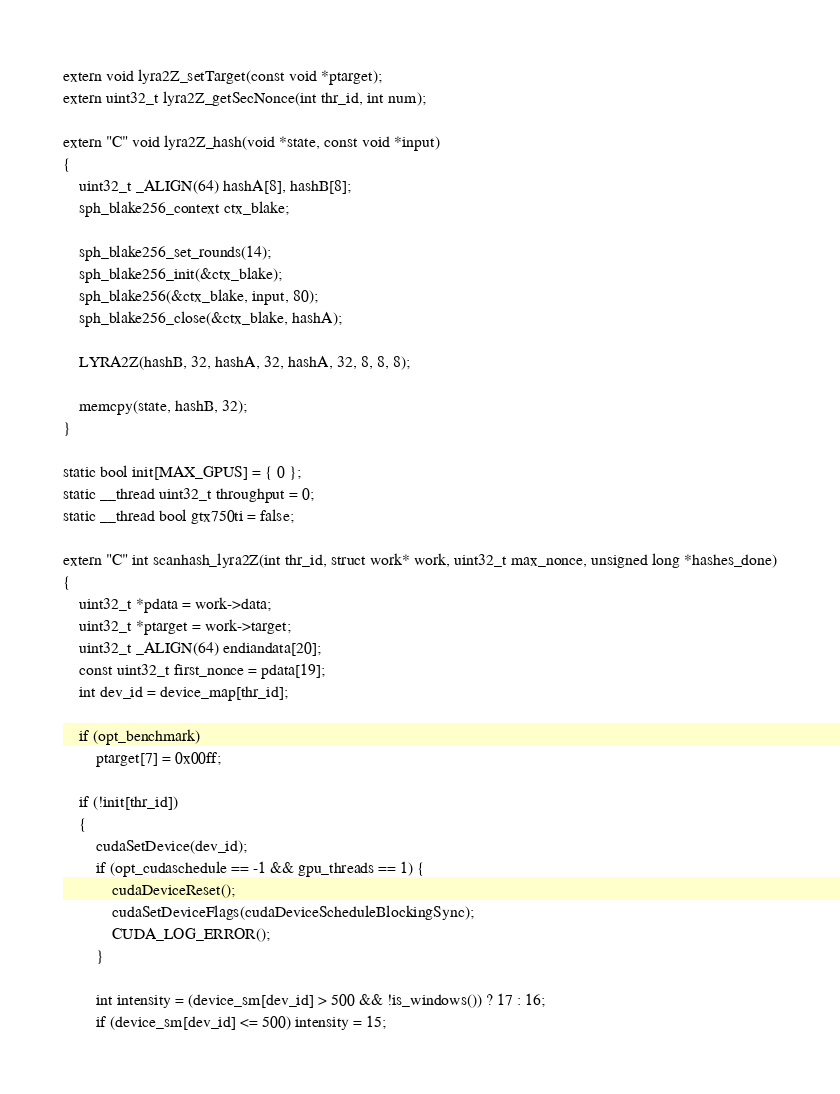<code> <loc_0><loc_0><loc_500><loc_500><_Cuda_>
extern void lyra2Z_setTarget(const void *ptarget);
extern uint32_t lyra2Z_getSecNonce(int thr_id, int num);

extern "C" void lyra2Z_hash(void *state, const void *input)
{
	uint32_t _ALIGN(64) hashA[8], hashB[8];
	sph_blake256_context ctx_blake;

	sph_blake256_set_rounds(14);
	sph_blake256_init(&ctx_blake);
	sph_blake256(&ctx_blake, input, 80);
	sph_blake256_close(&ctx_blake, hashA);

	LYRA2Z(hashB, 32, hashA, 32, hashA, 32, 8, 8, 8);

	memcpy(state, hashB, 32);
}

static bool init[MAX_GPUS] = { 0 };
static __thread uint32_t throughput = 0;
static __thread bool gtx750ti = false;

extern "C" int scanhash_lyra2Z(int thr_id, struct work* work, uint32_t max_nonce, unsigned long *hashes_done)
{
	uint32_t *pdata = work->data;
	uint32_t *ptarget = work->target;
	uint32_t _ALIGN(64) endiandata[20];
	const uint32_t first_nonce = pdata[19];
	int dev_id = device_map[thr_id];

	if (opt_benchmark)
		ptarget[7] = 0x00ff;

	if (!init[thr_id])
	{
		cudaSetDevice(dev_id);
		if (opt_cudaschedule == -1 && gpu_threads == 1) {
			cudaDeviceReset();
			cudaSetDeviceFlags(cudaDeviceScheduleBlockingSync);
			CUDA_LOG_ERROR();
		}

		int intensity = (device_sm[dev_id] > 500 && !is_windows()) ? 17 : 16;
		if (device_sm[dev_id] <= 500) intensity = 15;</code> 